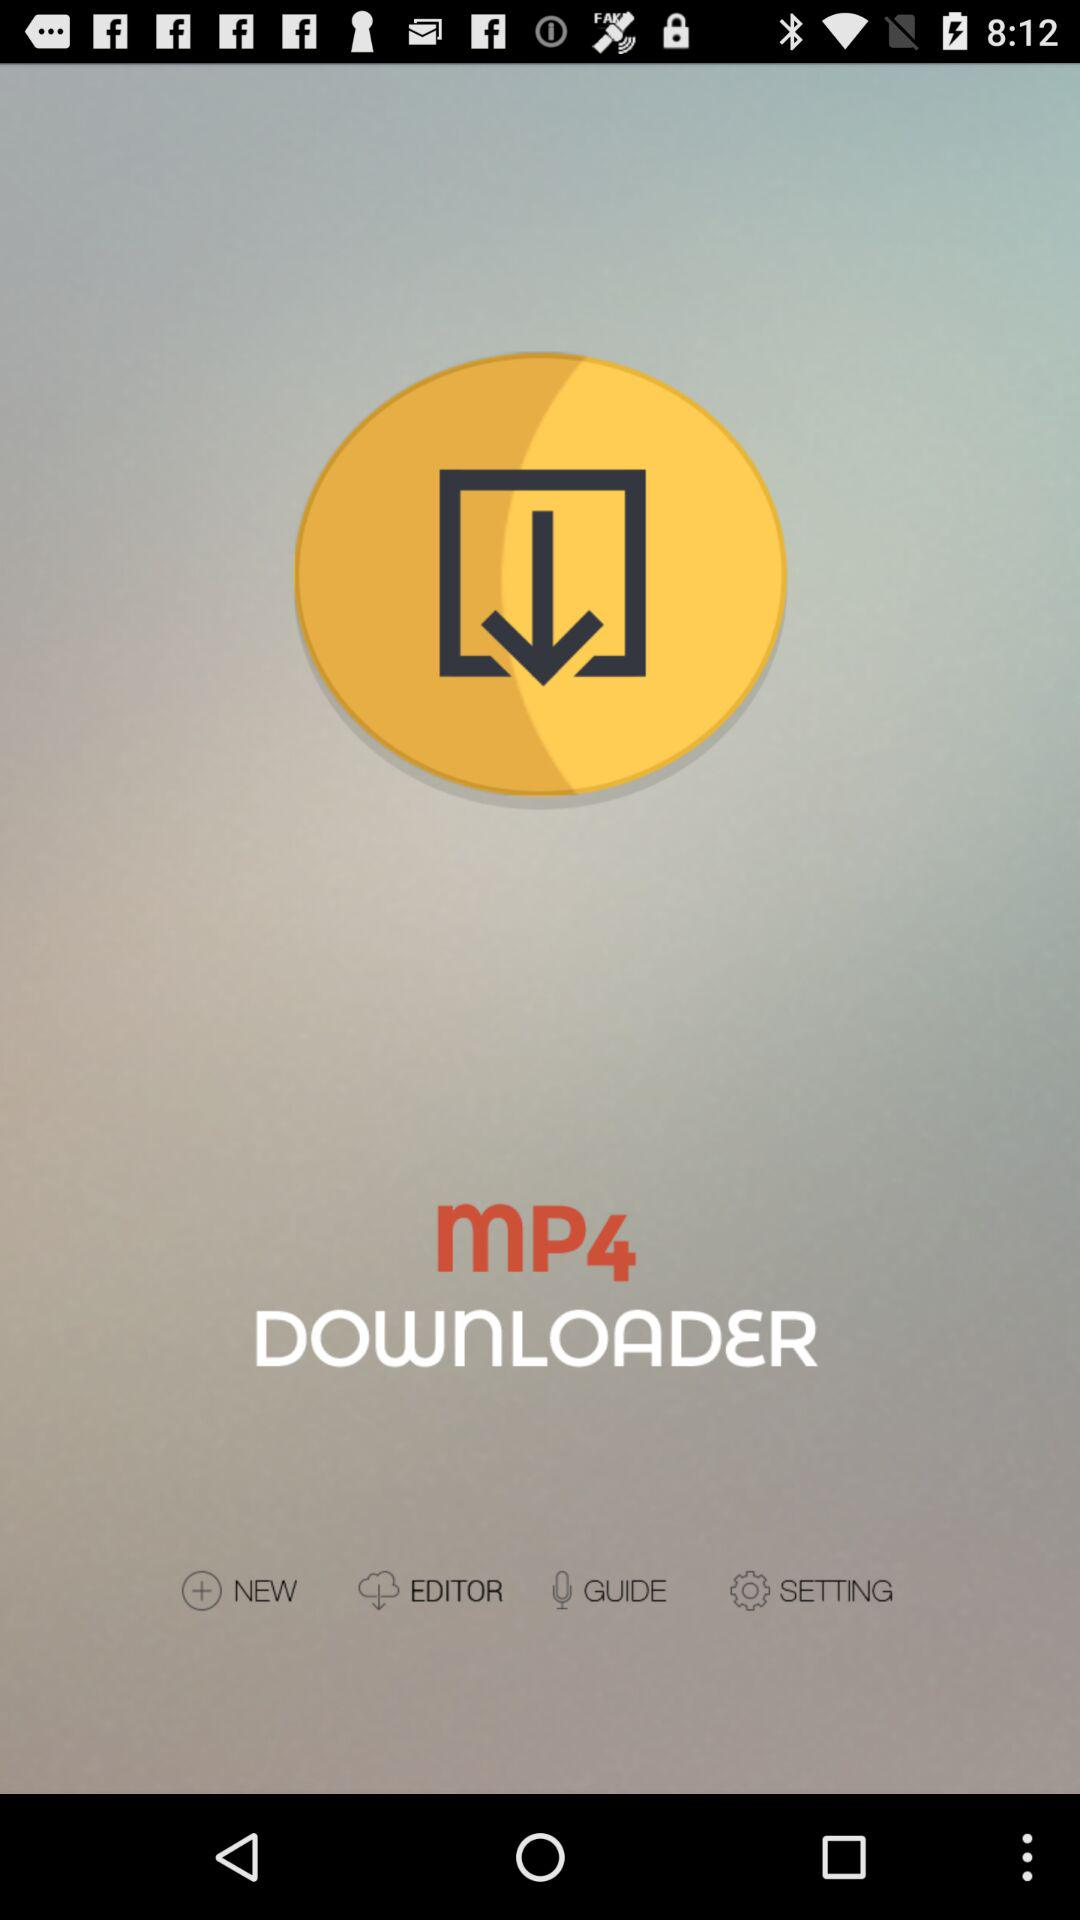What is the application name? The application name is "MP4 DOWNLOADER". 